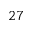<formula> <loc_0><loc_0><loc_500><loc_500>^ { 2 7 }</formula> 